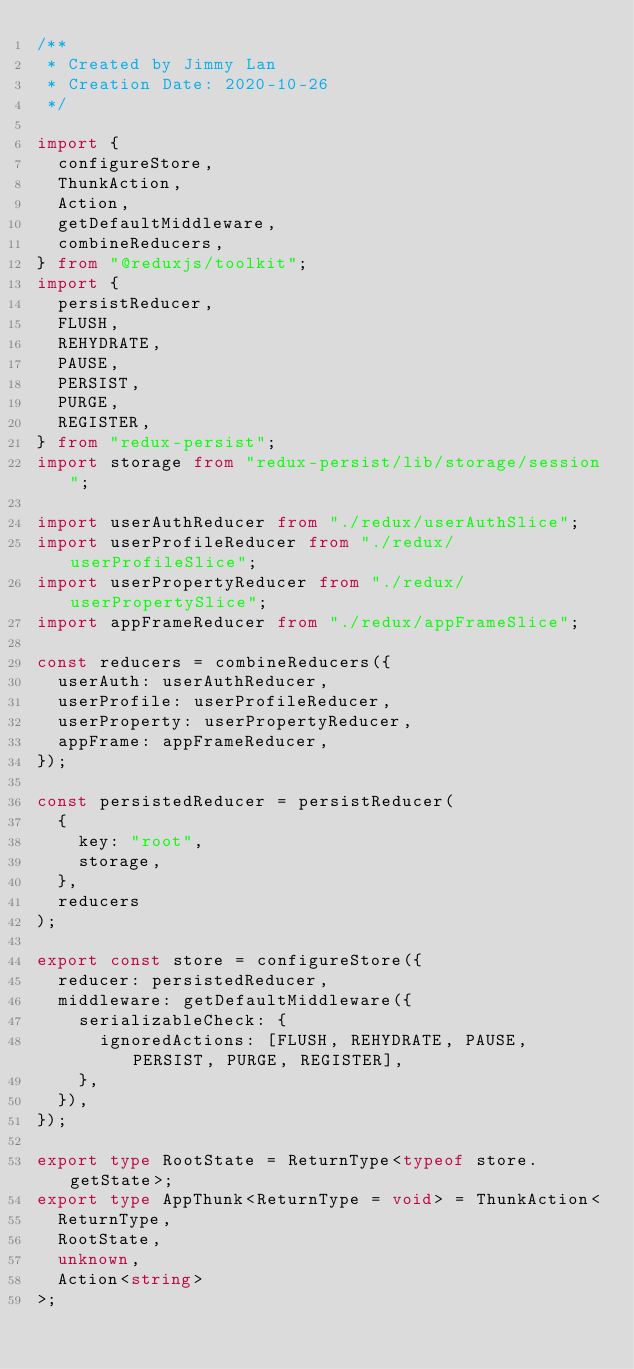Convert code to text. <code><loc_0><loc_0><loc_500><loc_500><_TypeScript_>/**
 * Created by Jimmy Lan
 * Creation Date: 2020-10-26
 */

import {
  configureStore,
  ThunkAction,
  Action,
  getDefaultMiddleware,
  combineReducers,
} from "@reduxjs/toolkit";
import {
  persistReducer,
  FLUSH,
  REHYDRATE,
  PAUSE,
  PERSIST,
  PURGE,
  REGISTER,
} from "redux-persist";
import storage from "redux-persist/lib/storage/session";

import userAuthReducer from "./redux/userAuthSlice";
import userProfileReducer from "./redux/userProfileSlice";
import userPropertyReducer from "./redux/userPropertySlice";
import appFrameReducer from "./redux/appFrameSlice";

const reducers = combineReducers({
  userAuth: userAuthReducer,
  userProfile: userProfileReducer,
  userProperty: userPropertyReducer,
  appFrame: appFrameReducer,
});

const persistedReducer = persistReducer(
  {
    key: "root",
    storage,
  },
  reducers
);

export const store = configureStore({
  reducer: persistedReducer,
  middleware: getDefaultMiddleware({
    serializableCheck: {
      ignoredActions: [FLUSH, REHYDRATE, PAUSE, PERSIST, PURGE, REGISTER],
    },
  }),
});

export type RootState = ReturnType<typeof store.getState>;
export type AppThunk<ReturnType = void> = ThunkAction<
  ReturnType,
  RootState,
  unknown,
  Action<string>
>;
</code> 